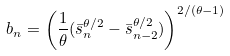<formula> <loc_0><loc_0><loc_500><loc_500>b _ { n } = \left ( \frac { 1 } { \theta } ( \bar { s } _ { n } ^ { \theta / 2 } - \bar { s } _ { n - 2 } ^ { \theta / 2 } ) \right ) ^ { 2 / ( \theta - 1 ) }</formula> 